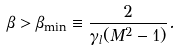Convert formula to latex. <formula><loc_0><loc_0><loc_500><loc_500>\beta > \beta _ { \min } \equiv \frac { 2 } { \gamma _ { l } ( M ^ { 2 } - 1 ) } .</formula> 